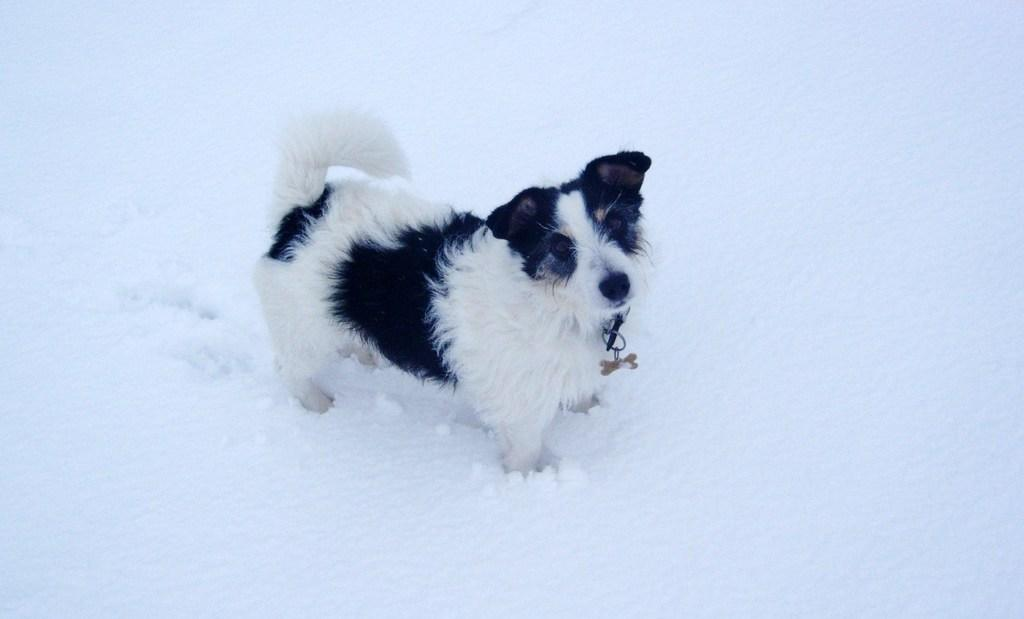What is the main subject in the center of the image? There is a dog in the center of the image. What is the condition of the ground in the image? The ground has snow in the image. How many beds can be seen in the image? There are no beds present in the image. What type of toad is sitting on the dog's head in the image? There is no toad present in the image, and therefore no such interaction can be observed. 